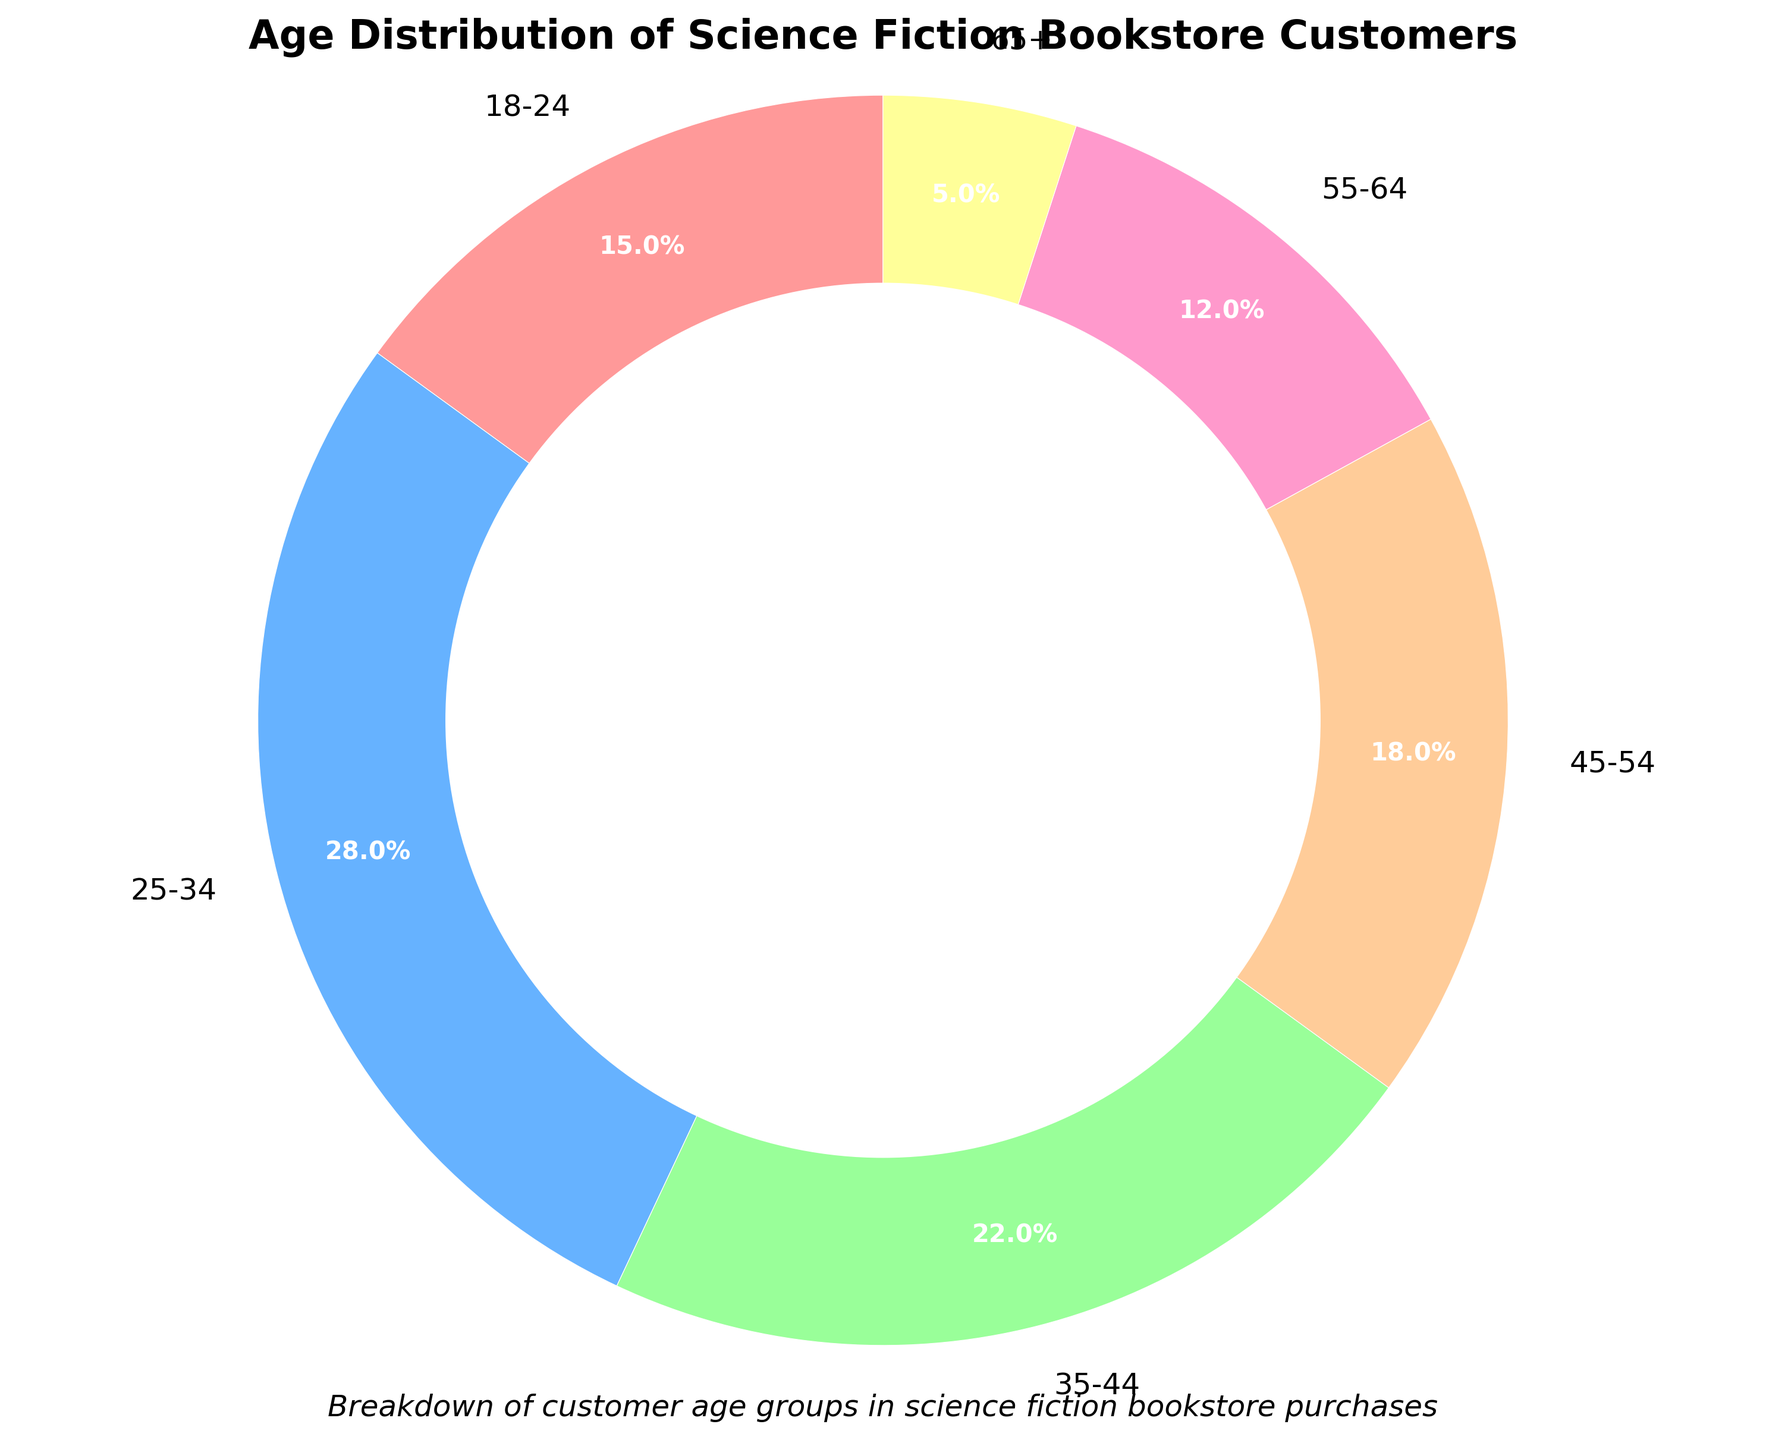What age group has the highest percentage of customers? The age group 25-34 has the highest percentage, as indicated by the largest slice of the pie chart, which is labeled 28%.
Answer: 25-34 Which two age groups have the closest percentages? The age groups 45-54 and 55-64 have the closest percentages: 18% and 12% respectively. This is the smallest difference between consecutive age groups in the chart.
Answer: 45-54 and 55-64 What is the combined percentage of customers aged 45 and above? The age groups 45-54, 55-64, and 65+ together make up (18% + 12% + 5%) = 35% of the customers.
Answer: 35% Is the percentage of customers aged 25-34 greater than the combined percentage of those aged 55 and above? Yes, the percentage of customers aged 25-34 is 28%, which is greater than the combined percentage of the 55-64 and 65+ age groups (12% + 5% = 17%).
Answer: Yes By how much does the youngest age group's percentage differ from the oldest age group's? The 18-24 age group is 15% and the 65+ age group is 5%, so the difference is (15% - 5%) = 10%.
Answer: 10% Which age groups together represent exactly half of the customers? The age groups 25-34 and 35-44 together represent (28% + 22%) = 50% of the customers, exactly half.
Answer: 25-34 and 35-44 What color is used to represent the age group with the smallest percentage? The age group 65+ is represented with a yellow color in the pie chart, which corresponds to their 5% slice.
Answer: Yellow If the store wants to focus a marketing campaign on half of its customer base, which age range should they target? The store should target the 25-44 age range, as the 25-34 and 35-44 age groups together represent 50% of the customer base (28% + 22%).
Answer: 25-44 